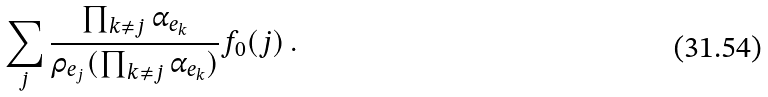<formula> <loc_0><loc_0><loc_500><loc_500>\sum _ { j } \frac { \prod _ { k \neq j } \alpha _ { e _ { k } } } { \rho _ { e _ { j } } ( \prod _ { k \neq j } \alpha _ { e _ { k } } ) } f _ { 0 } ( j ) \, .</formula> 